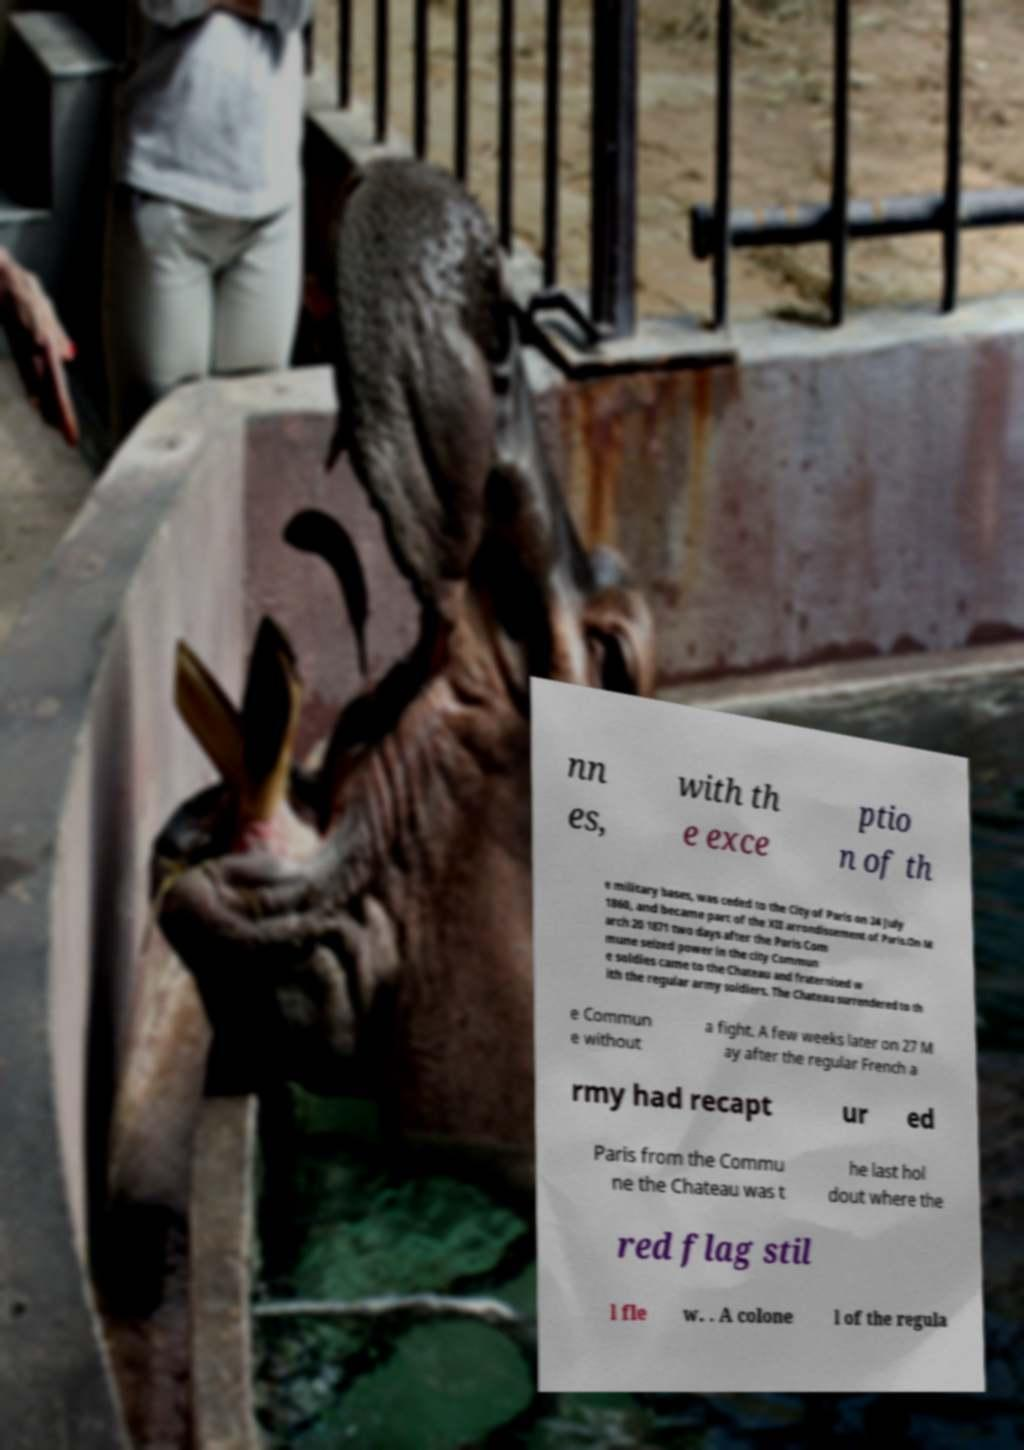Can you read and provide the text displayed in the image?This photo seems to have some interesting text. Can you extract and type it out for me? nn es, with th e exce ptio n of th e military bases, was ceded to the City of Paris on 24 July 1860, and became part of the XII arrondissement of Paris.On M arch 20 1871 two days after the Paris Com mune seized power in the city Commun e soldies came to the Chateau and fraternised w ith the regular army soldiers. The Chateau surrendered to th e Commun e without a fight. A few weeks later on 27 M ay after the regular French a rmy had recapt ur ed Paris from the Commu ne the Chateau was t he last hol dout where the red flag stil l fle w. . A colone l of the regula 